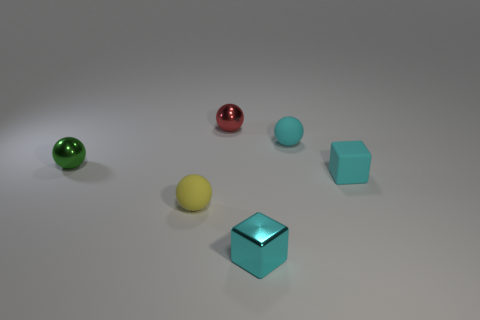What shape is the small metallic object that is the same color as the rubber cube?
Give a very brief answer. Cube. There is a small metallic object that is both behind the small shiny cube and on the right side of the tiny yellow rubber object; what shape is it?
Your answer should be compact. Sphere. What color is the rubber block that is the same size as the cyan rubber sphere?
Provide a short and direct response. Cyan. Are there any balls of the same color as the tiny matte cube?
Offer a terse response. Yes. Do the metal ball to the left of the yellow rubber ball and the rubber ball that is to the right of the red ball have the same size?
Give a very brief answer. Yes. There is a tiny object that is in front of the cyan matte block and to the left of the tiny cyan shiny block; what material is it?
Your answer should be very brief. Rubber. There is a ball that is the same color as the rubber cube; what is its size?
Offer a terse response. Small. What number of other things are there of the same size as the cyan sphere?
Offer a very short reply. 5. There is a small cyan object that is behind the tiny green sphere; what is it made of?
Keep it short and to the point. Rubber. Is the shape of the tiny cyan metallic object the same as the red thing?
Keep it short and to the point. No. 